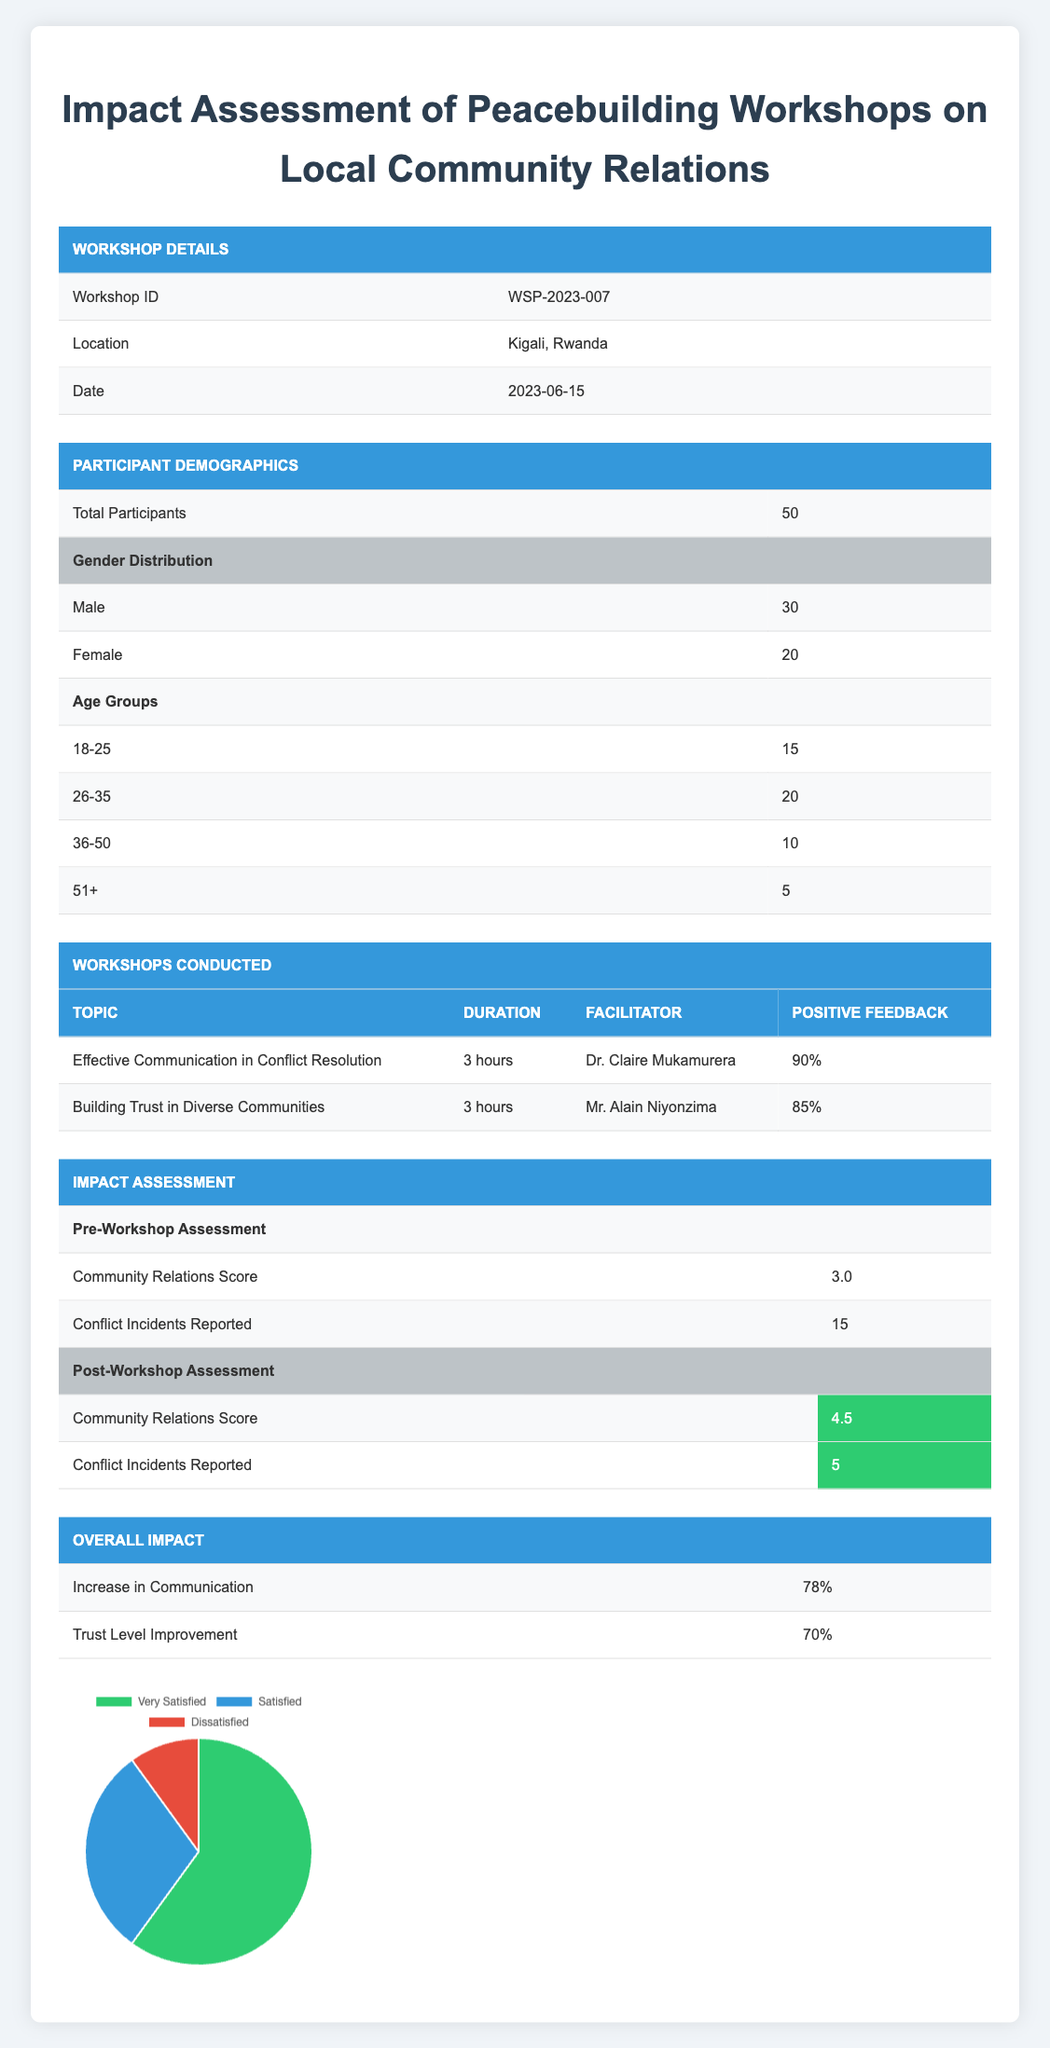What is the total number of participants in the workshop? The table specifies that the total number of participants is listed under the "Participants" section, which is directly shown to be 50.
Answer: 50 How many male participants were there? According to the "Gender Distribution" subsection, the number of male participants is specified as 30.
Answer: 30 What was the positive feedback percentage for the workshop on "Building Trust in Diverse Communities"? In the "Workshops Conducted" section, the feedback for this specific workshop indicates a positive feedback percentage of 85%.
Answer: 85% What is the difference in the Community Relations Score from pre-workshop to post-workshop? The pre-workshop Community Relations Score is 3.0 and the post-workshop score is 4.5. The difference is calculated by subtracting the pre-workshop score from the post-workshop score: 4.5 - 3.0 = 1.5.
Answer: 1.5 Did the number of conflict incidents reported decrease after the workshop? The pre-workshop data shows 15 conflict incidents reported, and the post-workshop data shows 5. Since 5 is less than 15, it indicates a decrease.
Answer: Yes What percentage of participants reported being very satisfied with the workshop? In the "Overall Impact" section, it states that 60% of participants reported being very satisfied.
Answer: 60% How many participants fall into the age group of 26-35? The table lists the age groups under "Age Groups" and specifies that there are 20 participants in the age group of 26-35.
Answer: 20 What is the total percentage of participants who felt either "Very Satisfied" or "Satisfied"? To find this, we add the percentages of "Very Satisfied" (60%) and "Satisfied" (30%): 60 + 30 = 90%.
Answer: 90% Which workshop had a higher positive feedback percentage, and by how much? The "Effective Communication in Conflict Resolution" workshop received 90% positive feedback, while "Building Trust in Diverse Communities" received 85%. The difference is 90% - 85% = 5%.
Answer: Effective Communication by 5% 